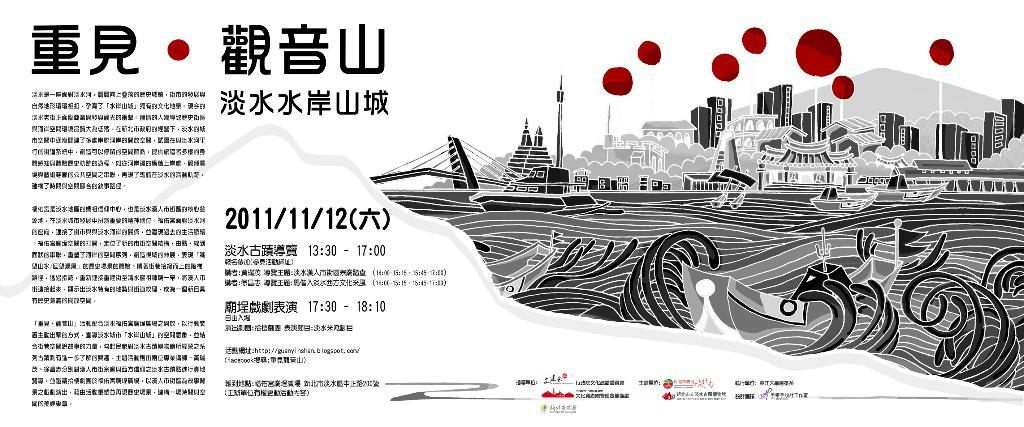What is present on the paper in the image? The paper has notes on it and a drawing. What type of content can be found on the paper? The paper contains notes and a drawing. What type of beef is being served at the edge of the paper in the image? There is no beef present in the image; it only features a paper with notes and a drawing. 